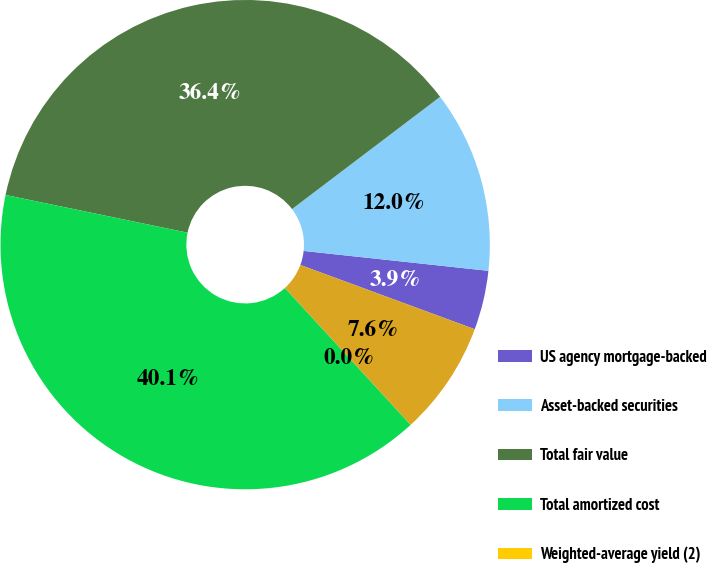Convert chart to OTSL. <chart><loc_0><loc_0><loc_500><loc_500><pie_chart><fcel>US agency mortgage-backed<fcel>Asset-backed securities<fcel>Total fair value<fcel>Total amortized cost<fcel>Weighted-average yield (2)<fcel>Corporate debt securities<nl><fcel>3.91%<fcel>12.03%<fcel>36.42%<fcel>40.07%<fcel>0.0%<fcel>7.56%<nl></chart> 